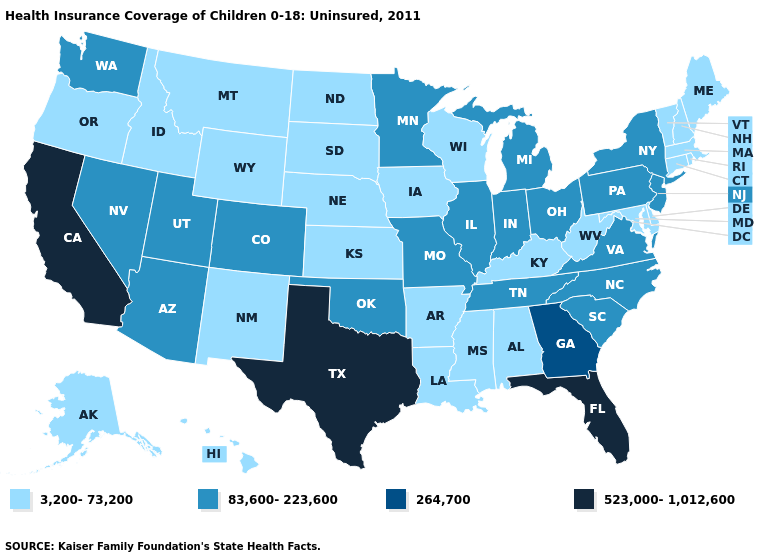Name the states that have a value in the range 523,000-1,012,600?
Concise answer only. California, Florida, Texas. What is the lowest value in the USA?
Keep it brief. 3,200-73,200. What is the value of Louisiana?
Short answer required. 3,200-73,200. Which states hav the highest value in the Northeast?
Answer briefly. New Jersey, New York, Pennsylvania. What is the value of New York?
Keep it brief. 83,600-223,600. What is the highest value in the Northeast ?
Answer briefly. 83,600-223,600. Does Alaska have a lower value than Michigan?
Write a very short answer. Yes. What is the lowest value in the MidWest?
Write a very short answer. 3,200-73,200. What is the value of Idaho?
Concise answer only. 3,200-73,200. What is the highest value in states that border Michigan?
Be succinct. 83,600-223,600. Among the states that border New Mexico , which have the highest value?
Be succinct. Texas. Does Florida have the lowest value in the USA?
Short answer required. No. Among the states that border Kansas , does Nebraska have the lowest value?
Keep it brief. Yes. Among the states that border Delaware , does Maryland have the lowest value?
Quick response, please. Yes. Does Texas have the highest value in the USA?
Write a very short answer. Yes. 